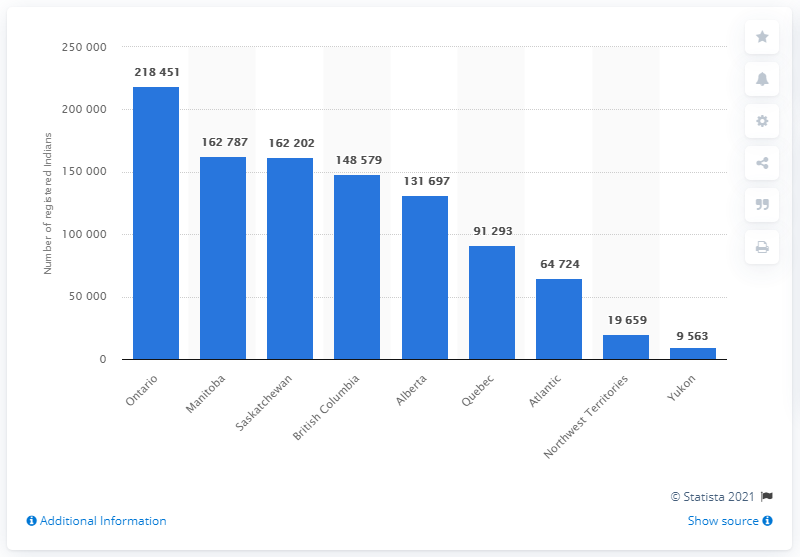Mention a couple of crucial points in this snapshot. As of December 2019, there were approximately 162,202 residents of Indian origin living in the province of Manitoba. As of December 2019, it is estimated that 218,451 people of Indian origin lived in Ontario. 